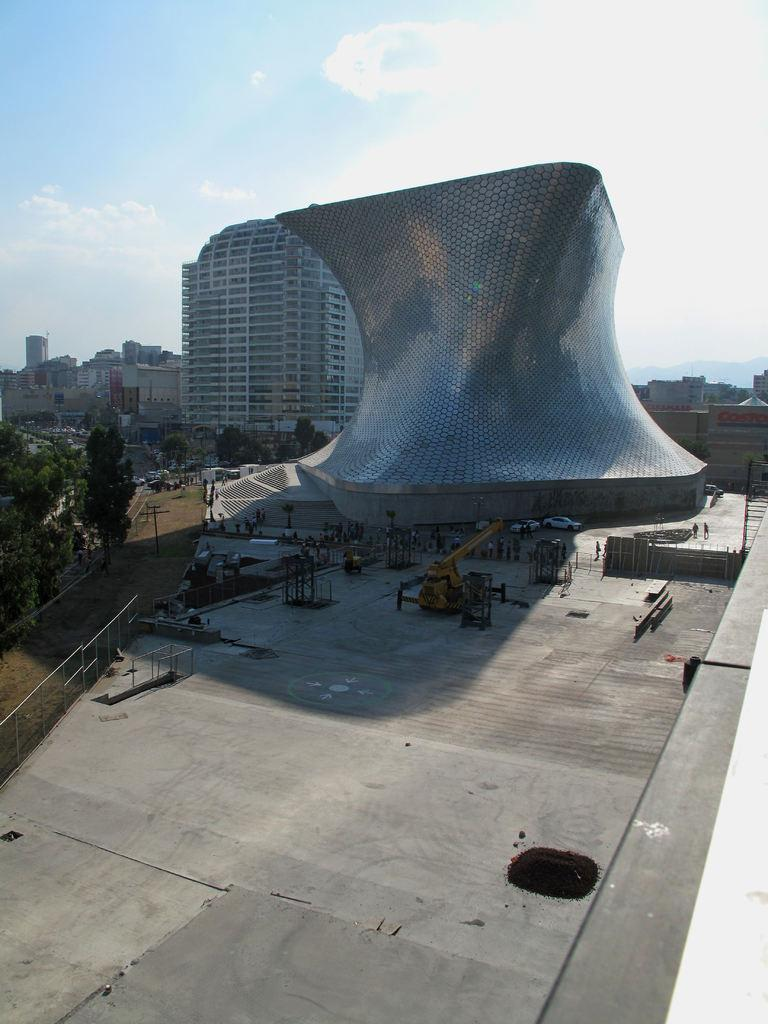What is the main subject of the image? There is a building with a unique shape in the image. Are there any other objects or structures near the building? Yes, there are other objects beside the building. What can be seen in the background of the image? There are other buildings and trees in the background of the image. How many snails can be seen crawling on the building in the image? There are no snails visible on the building in the image. What was the architect's afterthought when designing the building? The provided facts do not give any information about the architect's thought process or intentions, so we cannot answer this question. 